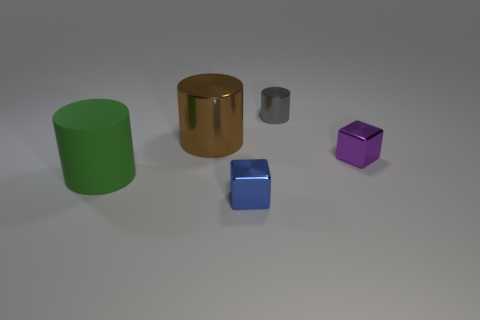Is there anything else that is the same size as the gray metallic object?
Offer a very short reply. Yes. Are there more purple metal blocks on the right side of the small purple cube than green rubber objects that are behind the tiny gray metallic cylinder?
Offer a very short reply. No. There is a blue metal thing left of the purple cube; does it have the same size as the green thing?
Give a very brief answer. No. What number of gray shiny cylinders are in front of the shiny cube that is behind the shiny object that is in front of the purple cube?
Your answer should be very brief. 0. What size is the metal thing that is behind the large green object and in front of the brown object?
Make the answer very short. Small. How many other things are the same shape as the tiny gray thing?
Ensure brevity in your answer.  2. How many matte cylinders are on the left side of the gray shiny cylinder?
Keep it short and to the point. 1. Is the number of purple objects left of the tiny metallic cylinder less than the number of small metal cylinders that are in front of the small blue shiny object?
Provide a short and direct response. No. What shape is the big green rubber thing behind the shiny block that is on the left side of the object that is to the right of the gray thing?
Make the answer very short. Cylinder. The metallic thing that is behind the purple shiny cube and in front of the tiny gray metal cylinder has what shape?
Provide a succinct answer. Cylinder. 